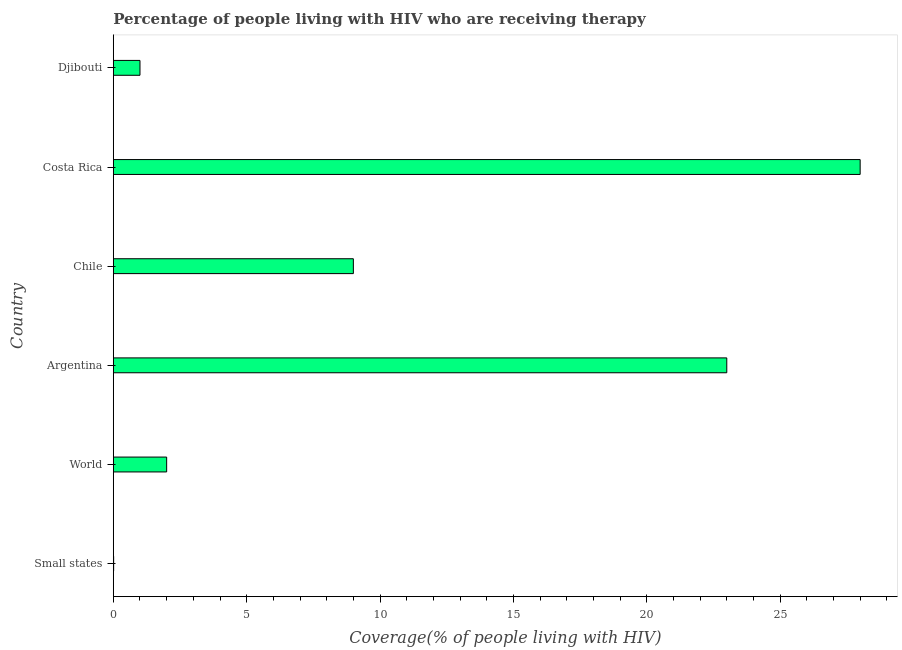Does the graph contain any zero values?
Your answer should be very brief. No. Does the graph contain grids?
Make the answer very short. No. What is the title of the graph?
Offer a very short reply. Percentage of people living with HIV who are receiving therapy. What is the label or title of the X-axis?
Give a very brief answer. Coverage(% of people living with HIV). What is the antiretroviral therapy coverage in Chile?
Keep it short and to the point. 9. Across all countries, what is the maximum antiretroviral therapy coverage?
Your answer should be compact. 28. Across all countries, what is the minimum antiretroviral therapy coverage?
Offer a very short reply. 0.01. In which country was the antiretroviral therapy coverage maximum?
Provide a succinct answer. Costa Rica. In which country was the antiretroviral therapy coverage minimum?
Make the answer very short. Small states. What is the sum of the antiretroviral therapy coverage?
Your answer should be very brief. 63.01. What is the difference between the antiretroviral therapy coverage in Djibouti and World?
Your answer should be compact. -1. What is the average antiretroviral therapy coverage per country?
Offer a very short reply. 10.5. What is the median antiretroviral therapy coverage?
Give a very brief answer. 5.5. What is the difference between the highest and the second highest antiretroviral therapy coverage?
Ensure brevity in your answer.  5. What is the difference between the highest and the lowest antiretroviral therapy coverage?
Make the answer very short. 27.99. In how many countries, is the antiretroviral therapy coverage greater than the average antiretroviral therapy coverage taken over all countries?
Your answer should be compact. 2. How many bars are there?
Ensure brevity in your answer.  6. Are all the bars in the graph horizontal?
Your response must be concise. Yes. How many countries are there in the graph?
Provide a short and direct response. 6. What is the Coverage(% of people living with HIV) of Small states?
Make the answer very short. 0.01. What is the Coverage(% of people living with HIV) in Argentina?
Give a very brief answer. 23. What is the Coverage(% of people living with HIV) of Chile?
Ensure brevity in your answer.  9. What is the Coverage(% of people living with HIV) in Costa Rica?
Keep it short and to the point. 28. What is the difference between the Coverage(% of people living with HIV) in Small states and World?
Your response must be concise. -1.99. What is the difference between the Coverage(% of people living with HIV) in Small states and Argentina?
Keep it short and to the point. -22.99. What is the difference between the Coverage(% of people living with HIV) in Small states and Chile?
Make the answer very short. -8.99. What is the difference between the Coverage(% of people living with HIV) in Small states and Costa Rica?
Ensure brevity in your answer.  -27.99. What is the difference between the Coverage(% of people living with HIV) in Small states and Djibouti?
Provide a succinct answer. -0.99. What is the difference between the Coverage(% of people living with HIV) in Argentina and Costa Rica?
Provide a short and direct response. -5. What is the difference between the Coverage(% of people living with HIV) in Argentina and Djibouti?
Offer a terse response. 22. What is the difference between the Coverage(% of people living with HIV) in Chile and Costa Rica?
Ensure brevity in your answer.  -19. What is the difference between the Coverage(% of people living with HIV) in Costa Rica and Djibouti?
Your answer should be very brief. 27. What is the ratio of the Coverage(% of people living with HIV) in Small states to that in World?
Give a very brief answer. 0.01. What is the ratio of the Coverage(% of people living with HIV) in Small states to that in Argentina?
Offer a terse response. 0. What is the ratio of the Coverage(% of people living with HIV) in Small states to that in Djibouti?
Give a very brief answer. 0.01. What is the ratio of the Coverage(% of people living with HIV) in World to that in Argentina?
Offer a very short reply. 0.09. What is the ratio of the Coverage(% of people living with HIV) in World to that in Chile?
Provide a short and direct response. 0.22. What is the ratio of the Coverage(% of people living with HIV) in World to that in Costa Rica?
Provide a succinct answer. 0.07. What is the ratio of the Coverage(% of people living with HIV) in World to that in Djibouti?
Give a very brief answer. 2. What is the ratio of the Coverage(% of people living with HIV) in Argentina to that in Chile?
Offer a very short reply. 2.56. What is the ratio of the Coverage(% of people living with HIV) in Argentina to that in Costa Rica?
Provide a short and direct response. 0.82. What is the ratio of the Coverage(% of people living with HIV) in Argentina to that in Djibouti?
Offer a very short reply. 23. What is the ratio of the Coverage(% of people living with HIV) in Chile to that in Costa Rica?
Keep it short and to the point. 0.32. 